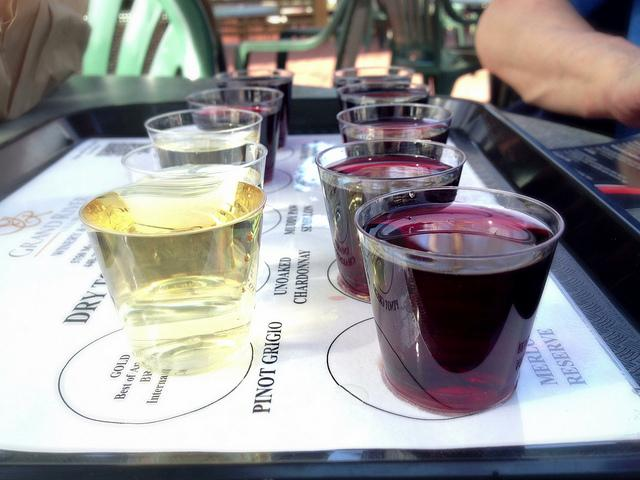What does the printing on the mat indicate? wine types 